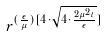<formula> <loc_0><loc_0><loc_500><loc_500>r ^ { ( \frac { \epsilon } { \mu } ) [ 4 \cdot \sqrt { 4 \cdot \frac { 2 \mu ^ { 2 } t } { \epsilon } } ] }</formula> 